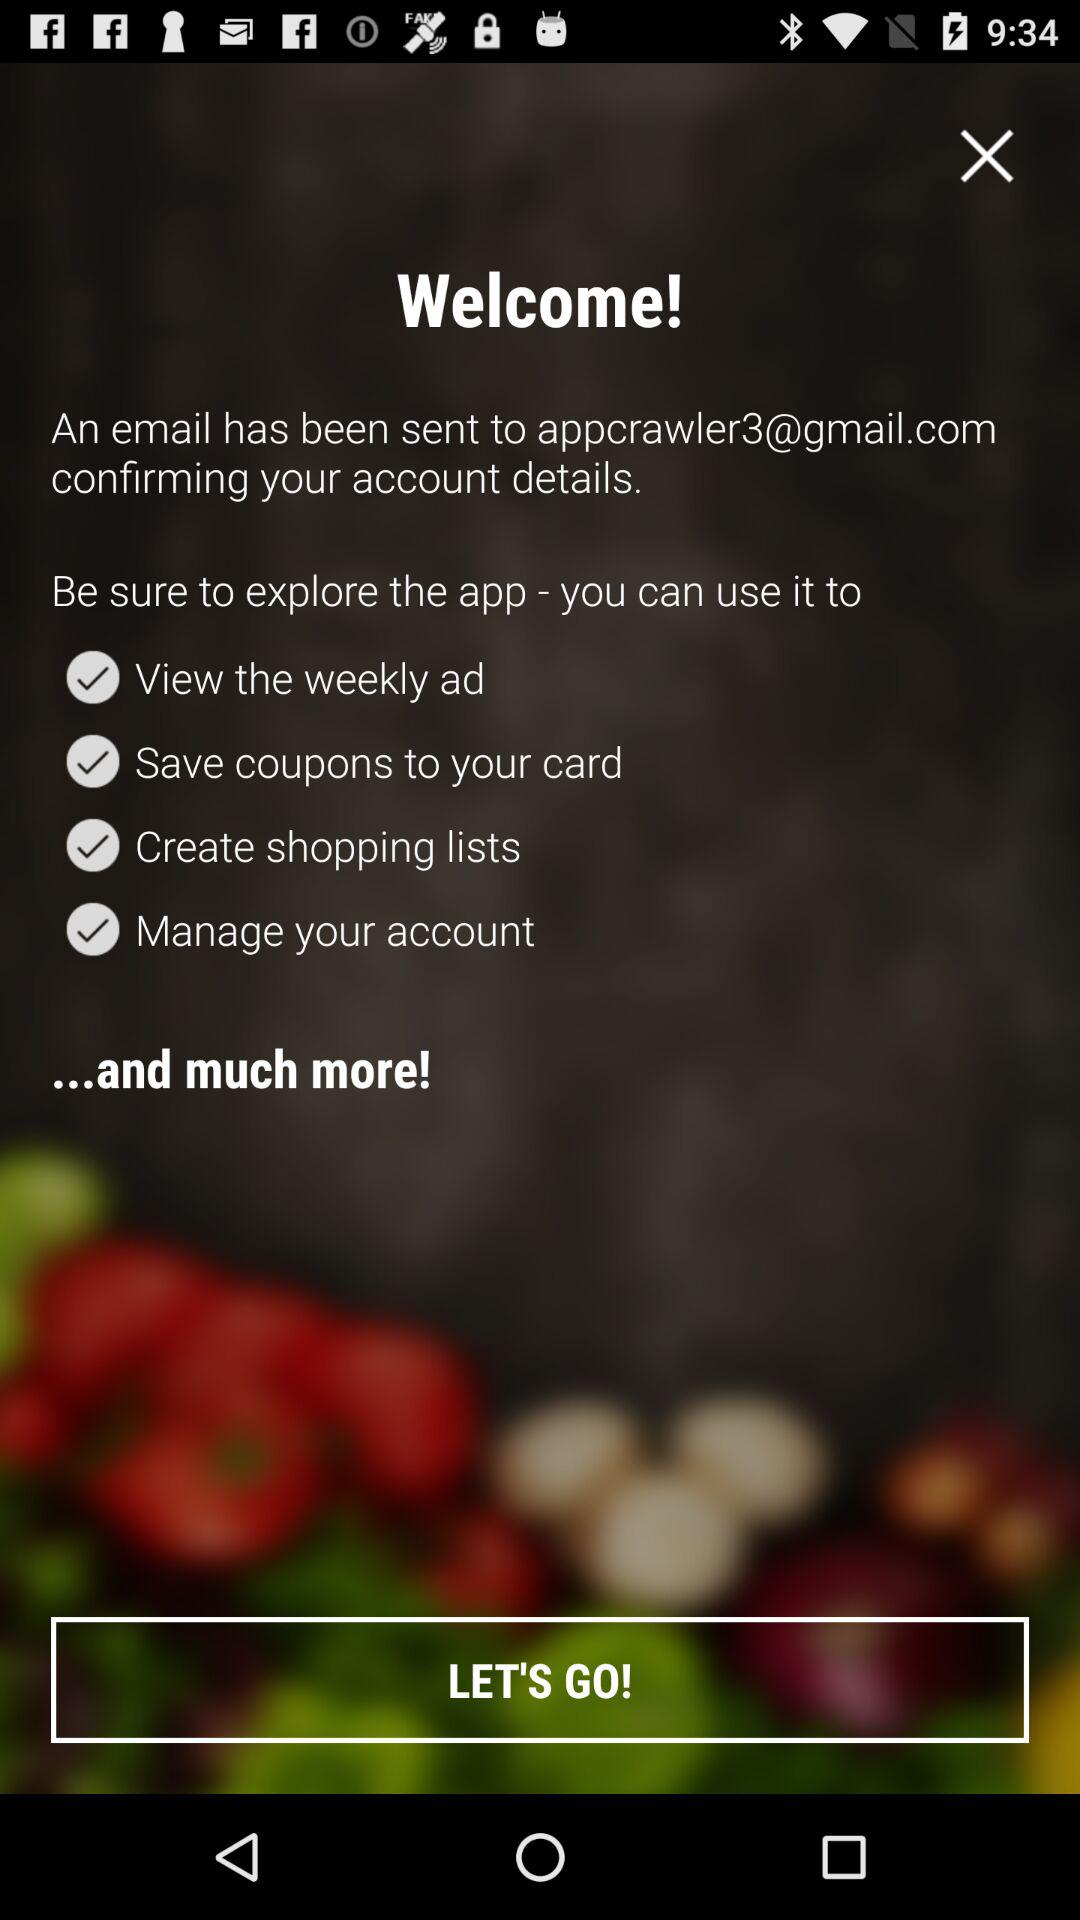What is the user's name?
When the provided information is insufficient, respond with <no answer>. <no answer> 